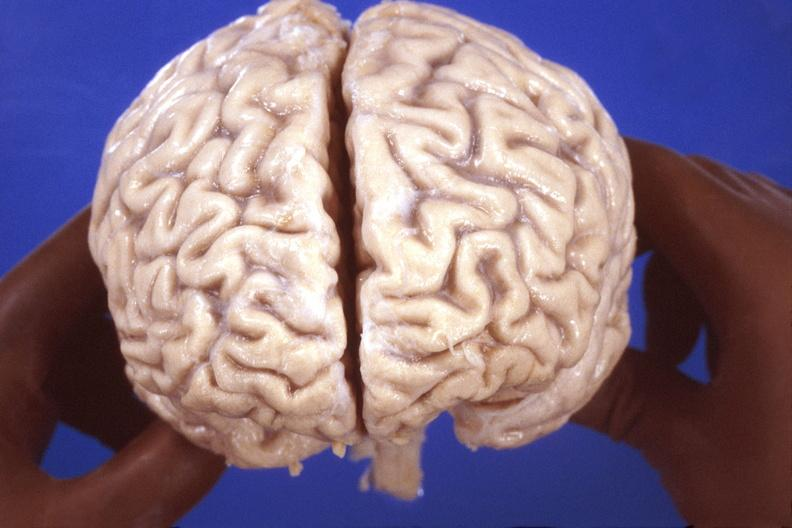s coronary atherosclerosis present?
Answer the question using a single word or phrase. No 